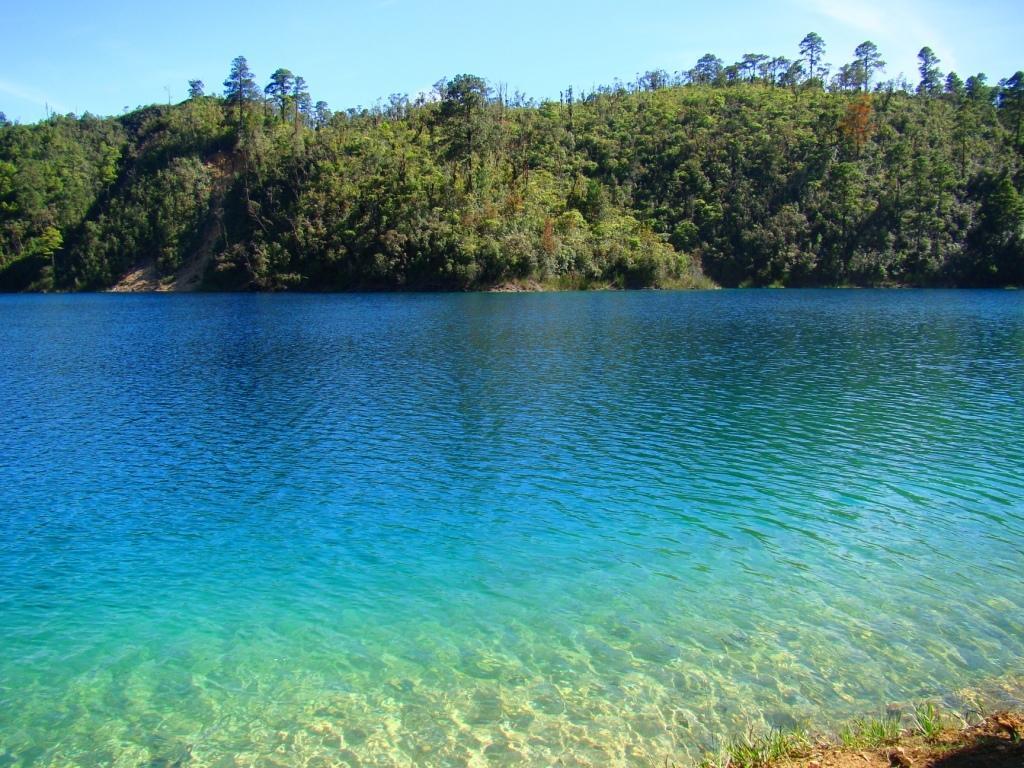Can you describe this image briefly? In the center of the image there is water. In the background there are trees and sky. 